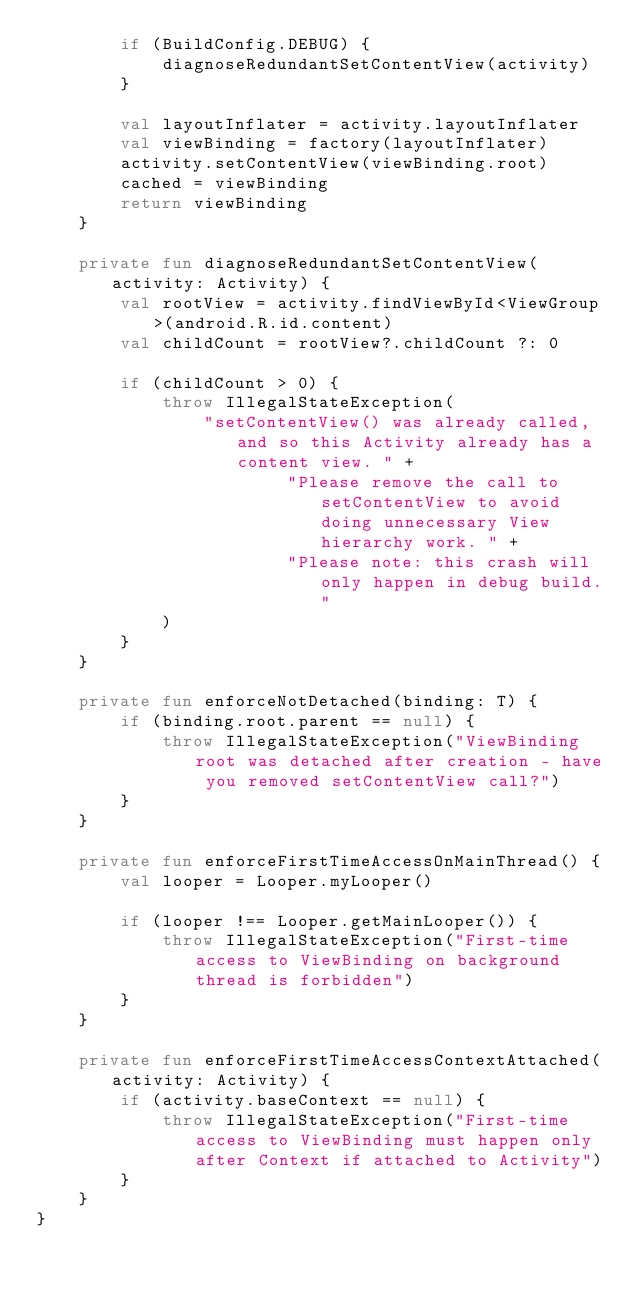<code> <loc_0><loc_0><loc_500><loc_500><_Kotlin_>		if (BuildConfig.DEBUG) {
			diagnoseRedundantSetContentView(activity)
		}

		val layoutInflater = activity.layoutInflater
		val viewBinding = factory(layoutInflater)
		activity.setContentView(viewBinding.root)
		cached = viewBinding
		return viewBinding
	}

	private fun diagnoseRedundantSetContentView(activity: Activity) {
		val rootView = activity.findViewById<ViewGroup>(android.R.id.content)
		val childCount = rootView?.childCount ?: 0

		if (childCount > 0) {
			throw IllegalStateException(
				"setContentView() was already called, and so this Activity already has a content view. " +
						"Please remove the call to setContentView to avoid doing unnecessary View hierarchy work. " +
						"Please note: this crash will only happen in debug build."
			)
		}
	}

	private fun enforceNotDetached(binding: T) {
		if (binding.root.parent == null) {
			throw IllegalStateException("ViewBinding root was detached after creation - have you removed setContentView call?")
		}
	}

	private fun enforceFirstTimeAccessOnMainThread() {
		val looper = Looper.myLooper()

		if (looper !== Looper.getMainLooper()) {
			throw IllegalStateException("First-time access to ViewBinding on background thread is forbidden")
		}
	}

	private fun enforceFirstTimeAccessContextAttached(activity: Activity) {
		if (activity.baseContext == null) {
			throw IllegalStateException("First-time access to ViewBinding must happen only after Context if attached to Activity")
		}
	}
}</code> 